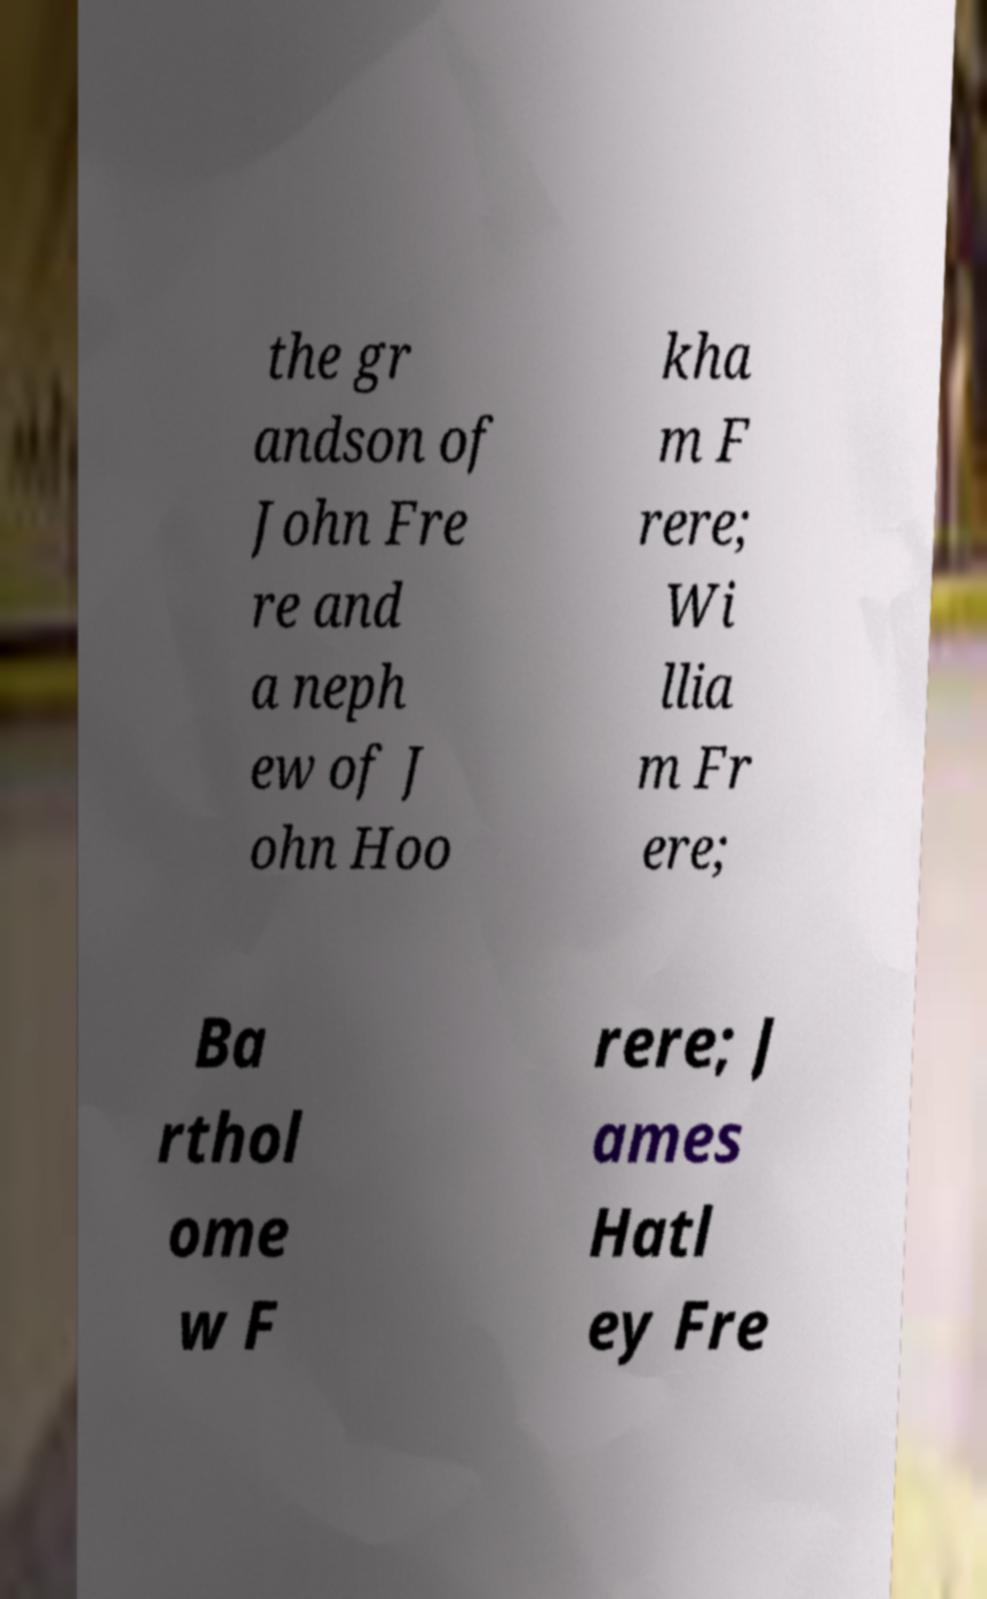Can you accurately transcribe the text from the provided image for me? the gr andson of John Fre re and a neph ew of J ohn Hoo kha m F rere; Wi llia m Fr ere; Ba rthol ome w F rere; J ames Hatl ey Fre 